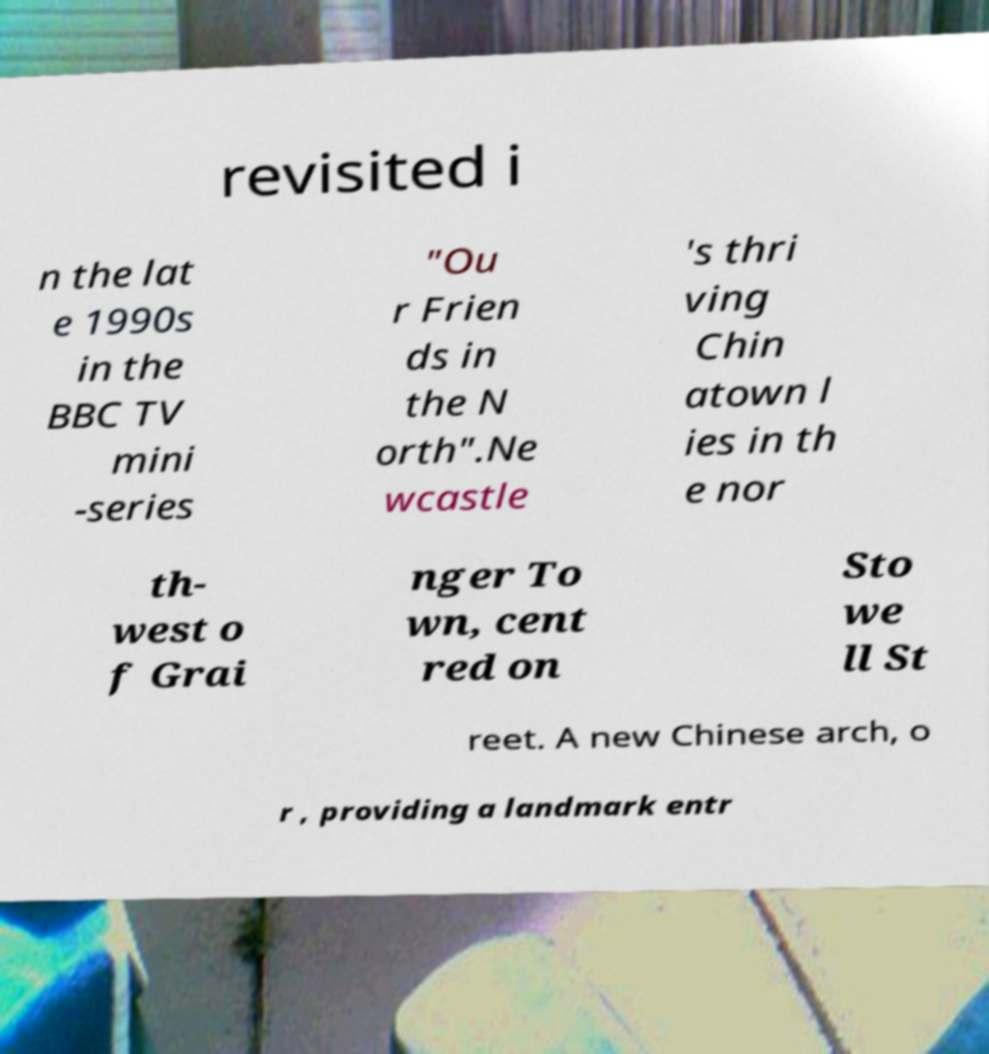There's text embedded in this image that I need extracted. Can you transcribe it verbatim? revisited i n the lat e 1990s in the BBC TV mini -series "Ou r Frien ds in the N orth".Ne wcastle 's thri ving Chin atown l ies in th e nor th- west o f Grai nger To wn, cent red on Sto we ll St reet. A new Chinese arch, o r , providing a landmark entr 